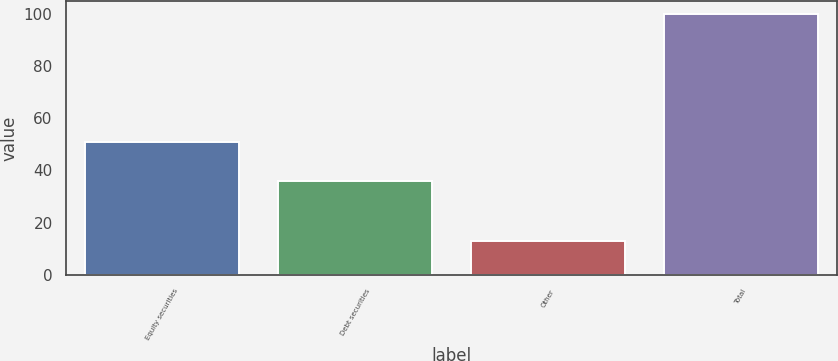Convert chart. <chart><loc_0><loc_0><loc_500><loc_500><bar_chart><fcel>Equity securities<fcel>Debt securities<fcel>Other<fcel>Total<nl><fcel>51<fcel>36<fcel>13<fcel>100<nl></chart> 